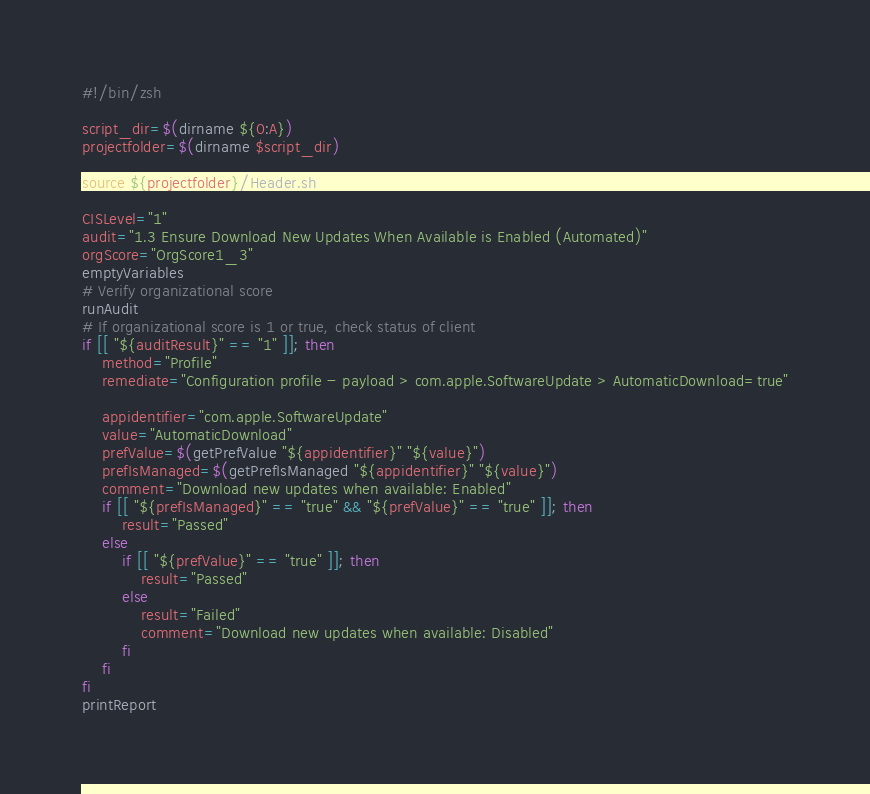Convert code to text. <code><loc_0><loc_0><loc_500><loc_500><_Bash_>#!/bin/zsh

script_dir=$(dirname ${0:A})
projectfolder=$(dirname $script_dir)

source ${projectfolder}/Header.sh

CISLevel="1"
audit="1.3 Ensure Download New Updates When Available is Enabled (Automated)"
orgScore="OrgScore1_3"
emptyVariables
# Verify organizational score
runAudit
# If organizational score is 1 or true, check status of client
if [[ "${auditResult}" == "1" ]]; then
	method="Profile"
	remediate="Configuration profile - payload > com.apple.SoftwareUpdate > AutomaticDownload=true"

	appidentifier="com.apple.SoftwareUpdate"
	value="AutomaticDownload"
	prefValue=$(getPrefValue "${appidentifier}" "${value}")
	prefIsManaged=$(getPrefIsManaged "${appidentifier}" "${value}")
	comment="Download new updates when available: Enabled"
	if [[ "${prefIsManaged}" == "true" && "${prefValue}" == "true" ]]; then
		result="Passed"
	else
		if [[ "${prefValue}" == "true" ]]; then
			result="Passed"
		else
			result="Failed"
			comment="Download new updates when available: Disabled"
		fi
	fi
fi
printReport</code> 